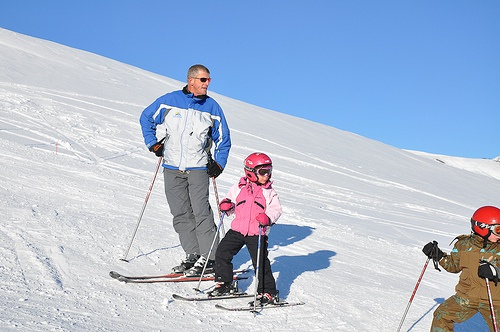Describe the objects in this image and their specific colors. I can see people in gray and lightgray tones, people in gray, black, lavender, lightpink, and salmon tones, people in gray, olive, brown, and black tones, skis in gray, lightgray, darkgray, and black tones, and skis in gray, lightgray, black, and darkgray tones in this image. 